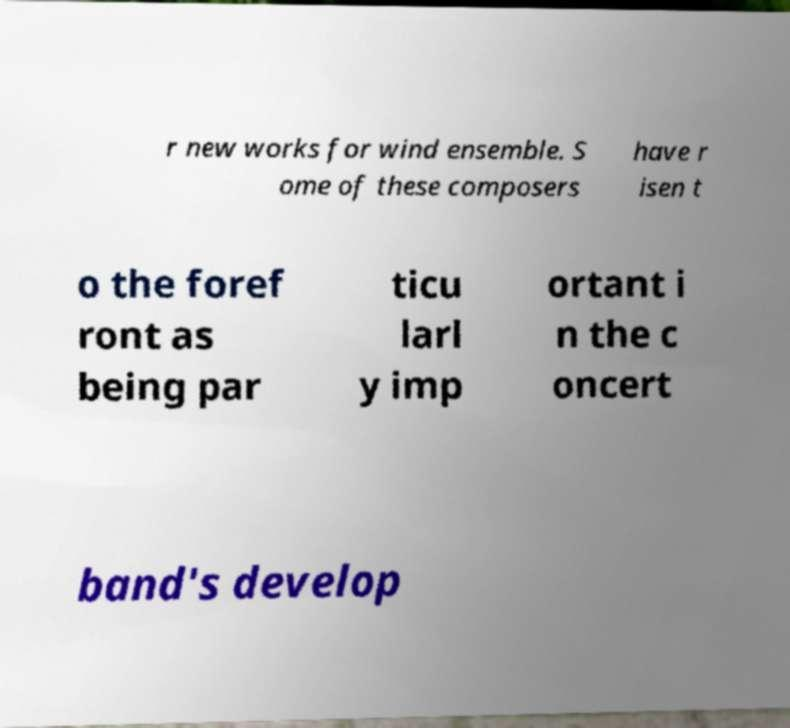Could you extract and type out the text from this image? r new works for wind ensemble. S ome of these composers have r isen t o the foref ront as being par ticu larl y imp ortant i n the c oncert band's develop 